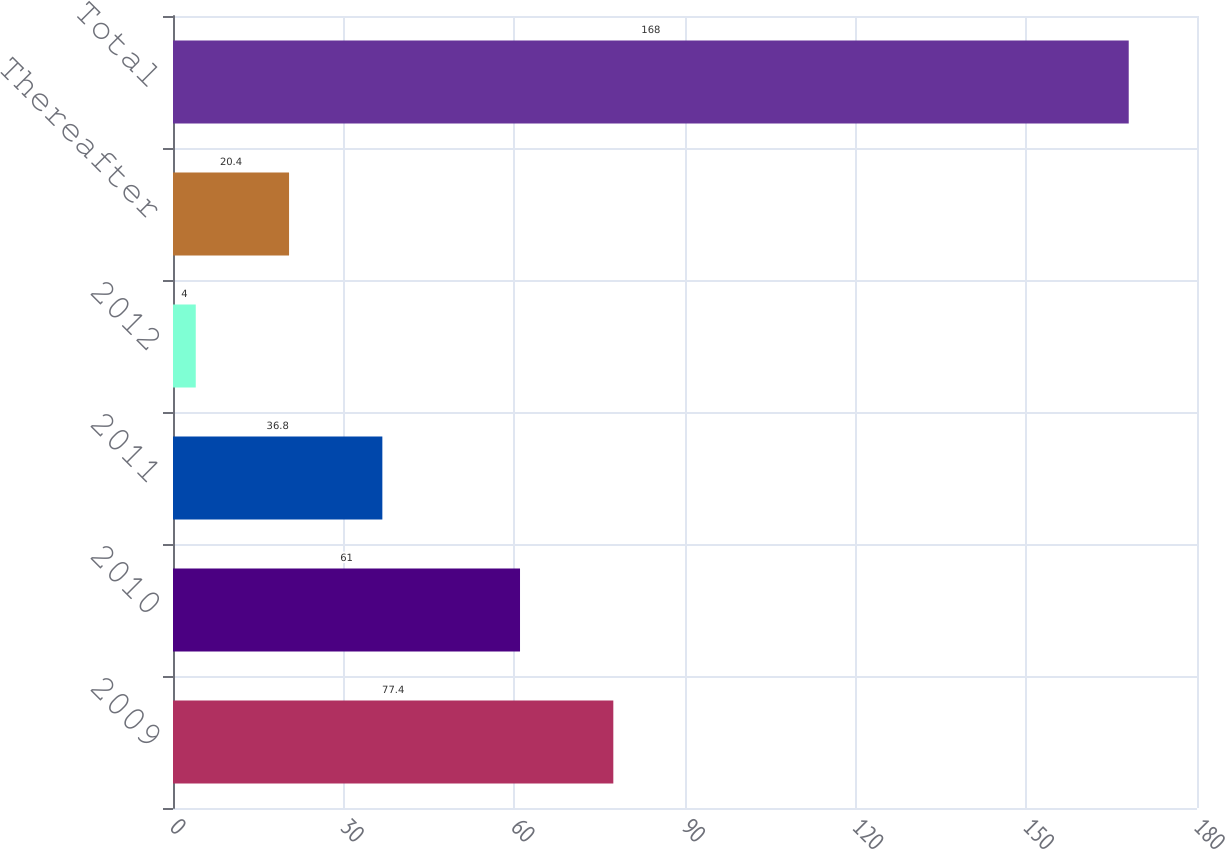Convert chart. <chart><loc_0><loc_0><loc_500><loc_500><bar_chart><fcel>2009<fcel>2010<fcel>2011<fcel>2012<fcel>Thereafter<fcel>Total<nl><fcel>77.4<fcel>61<fcel>36.8<fcel>4<fcel>20.4<fcel>168<nl></chart> 